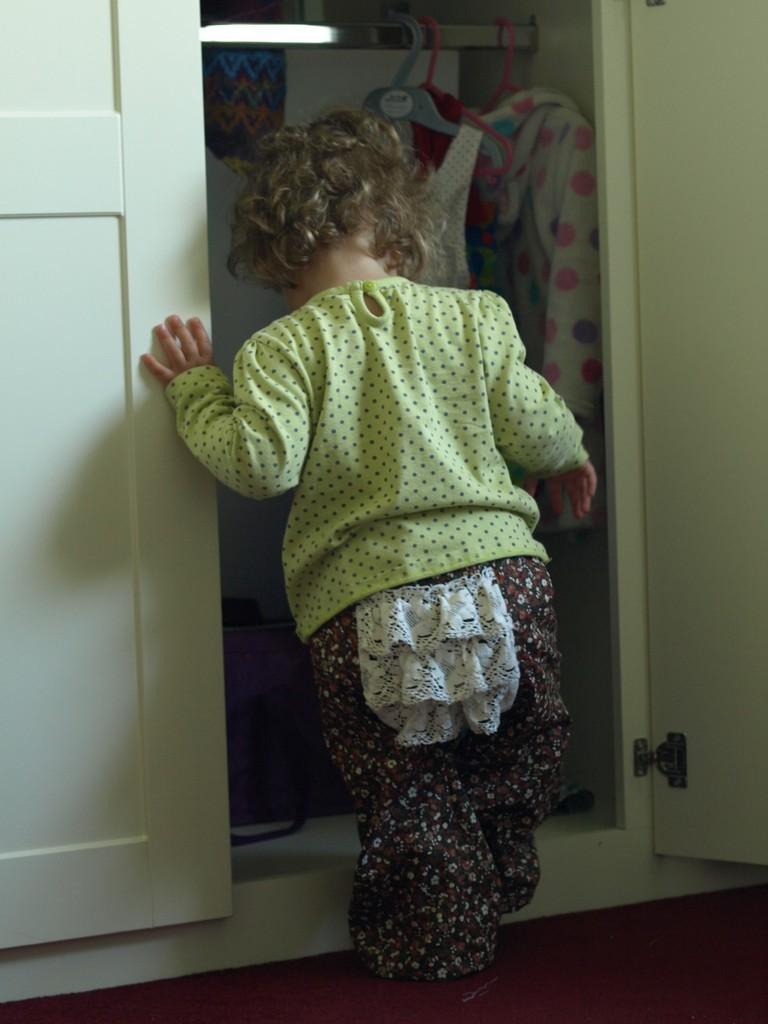Could you give a brief overview of what you see in this image? In this image a baby is walking and touching the door. There are some clothes which are changed to a hanger. 